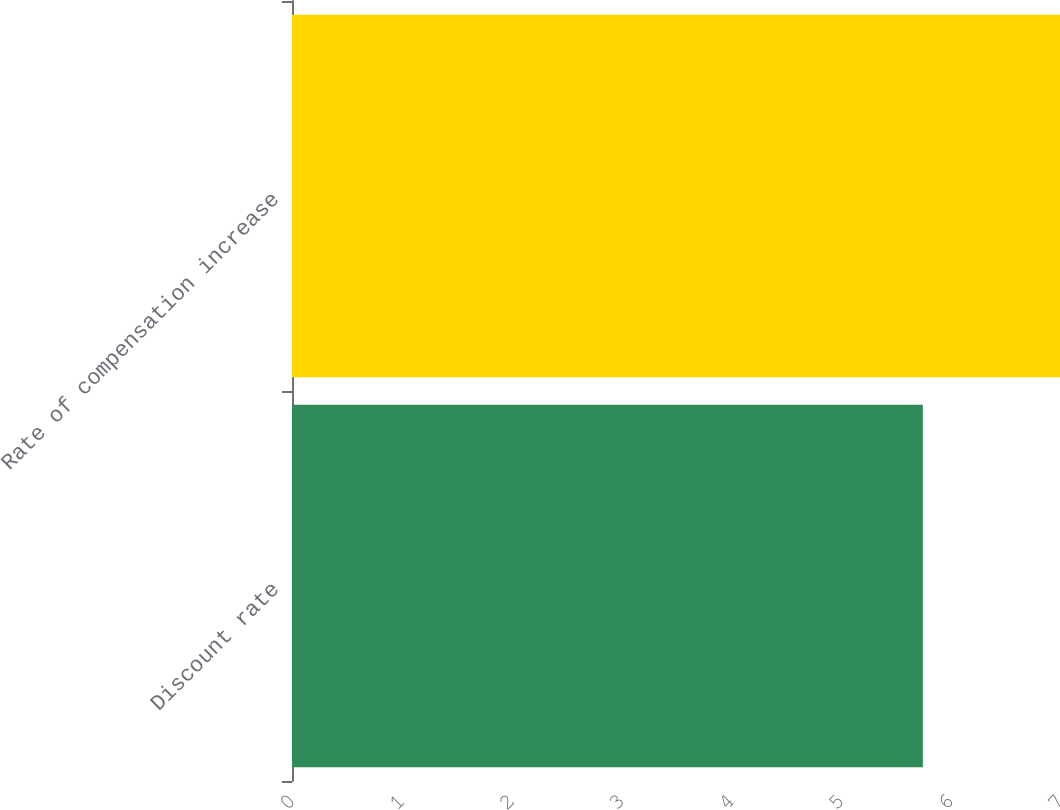Convert chart to OTSL. <chart><loc_0><loc_0><loc_500><loc_500><bar_chart><fcel>Discount rate<fcel>Rate of compensation increase<nl><fcel>5.75<fcel>7<nl></chart> 